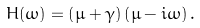<formula> <loc_0><loc_0><loc_500><loc_500>H ( \omega ) = \left ( \mu + \gamma \right ) \left ( \mu - i \omega \right ) .</formula> 